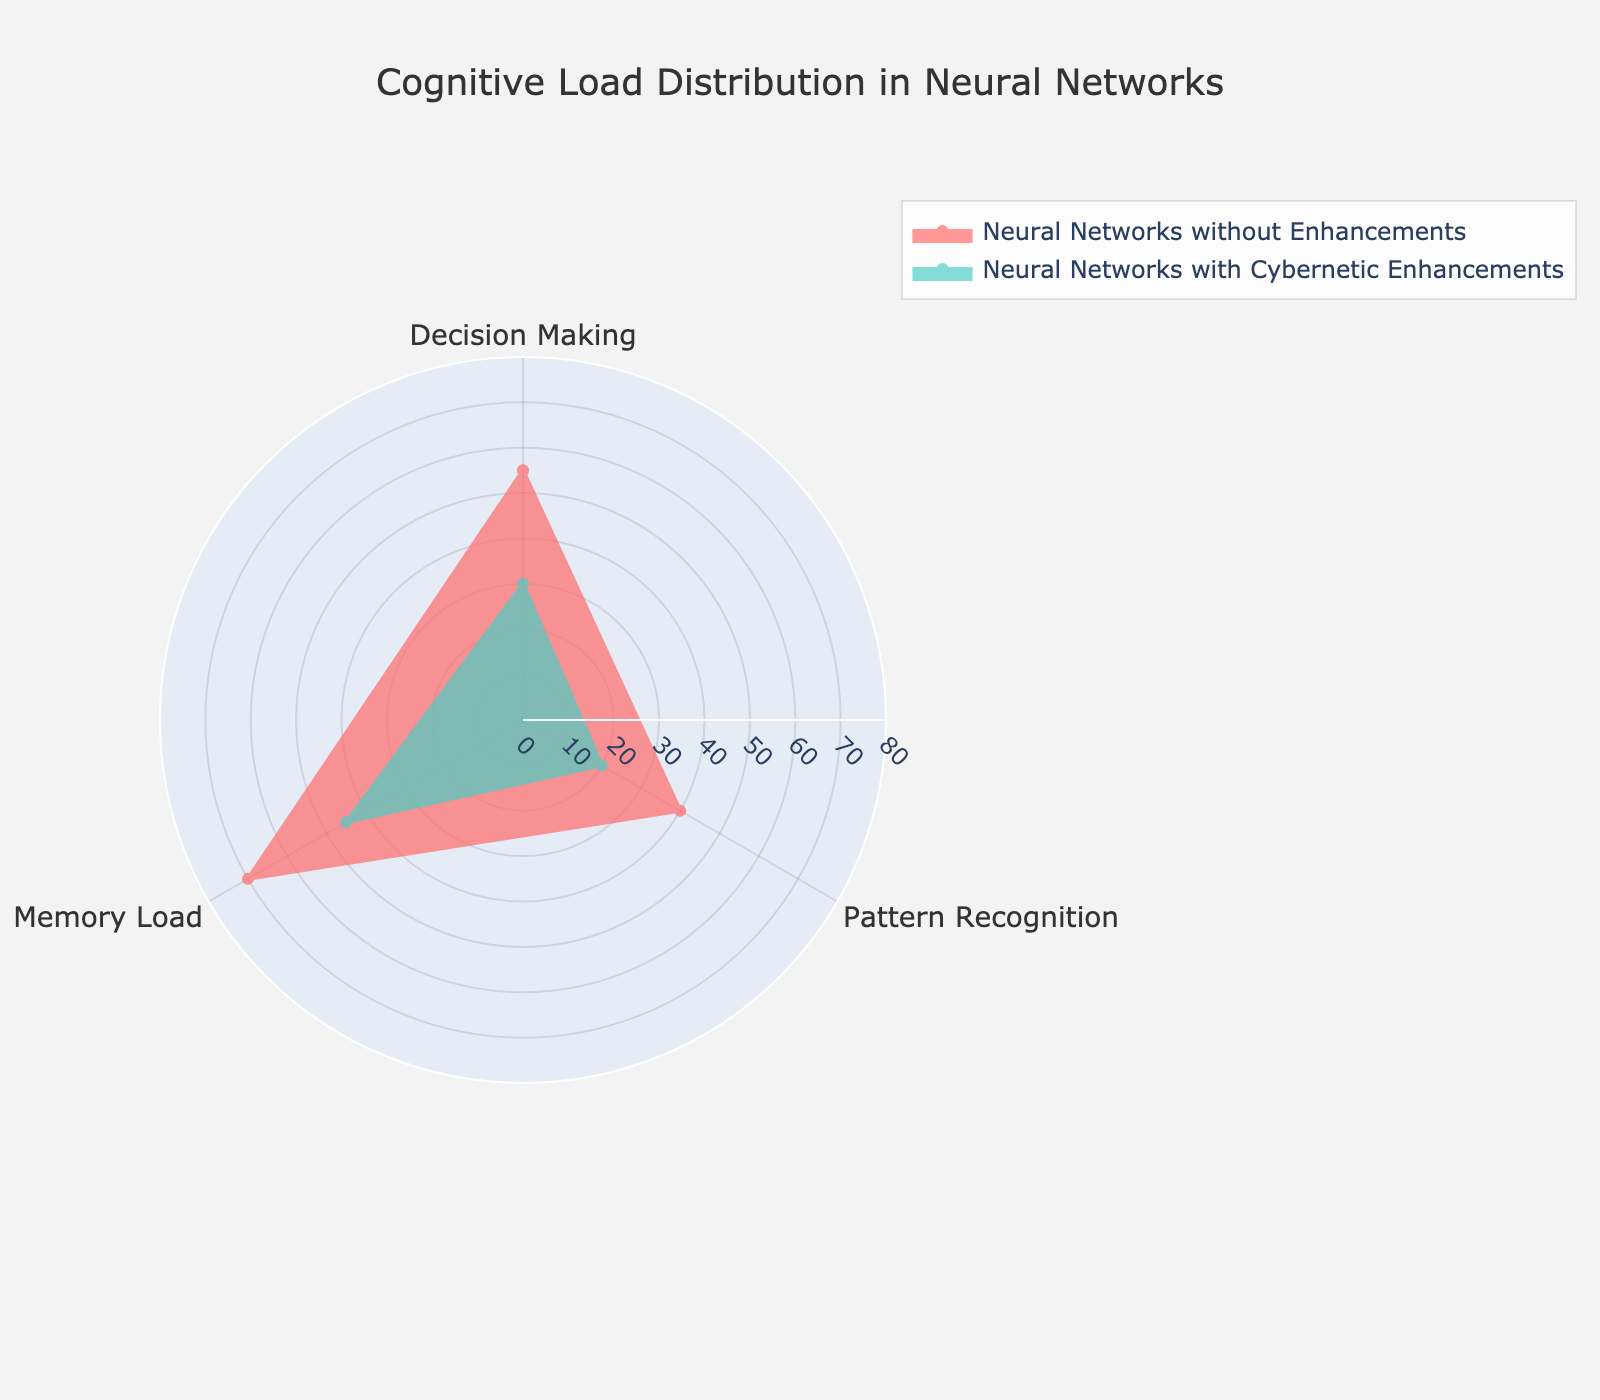what is the title of the chart? The title of the chart is displayed prominently at the top to provide context about the visualized data. It reads "Cognitive Load Distribution in Neural Networks".
Answer: Cognitive Load Distribution in Neural Networks what group does the color red represent? The red color in the chart represents the group "Neural Networks without Enhancements". This is usually indicated in the chart legend.
Answer: Neural Networks without Enhancements How many measures are compared in this chart? The chart compares three different measures: Decision Making, Pattern Recognition, and Memory Load. These are shown around the polar axis.
Answer: 3 Which measure has the highest cognitive load for Neural Networks with Cybernetic Enhancements? By looking at the area filled by the red and teal shapes, we can see that "Memory Load" has the highest cognitive load for Neural Networks with Cybernetic Enhancements, as it reaches the farthest from the center.
Answer: Memory Load How much higher is the Memory Load for Neural Networks without Enhancements compared to those with Cybernetic Enhancements? The Memory Load for Neural Networks without Enhancements is 70, whereas for those with Cybernetic Enhancements, it is 45. So, the difference is 70 - 45 = 25.
Answer: 25 Which group shows a lower cognitive load in Decision Making? The group "Neural Networks with Cybernetic Enhancements" shows a lower cognitive load in Decision Making with a value of 30, compared to "Neural Networks without Enhancements" which has a value of 55.
Answer: Neural Networks with Cybernetic Enhancements What is the average cognitive load for Neural Networks without Enhancements? To find the average, we sum up the cognitive loads for Decision Making (55), Pattern Recognition (40), and Memory Load (70), and divide by the number of measures (3). (55 + 40 + 70) / 3 = 165 / 3 = 55.
Answer: 55 Which group has a smaller variation in cognitive load across different measures? We can infer variation by looking at the differences in cognitive load values within each group. "Neural Networks with Cybernetic Enhancements" have cognitive loads of 30, 20, and 45, while "Neural Networks without Enhancements" have values of 55, 40, and 70. The variation appears smaller in the teal group as the range (45 - 20 = 25) is less than the range in the red group (70 - 40 = 30).
Answer: Neural Networks with Cybernetic Enhancements What is the combined cognitive load for Pattern Recognition across both groups? The cognitive load for Pattern Recognition is 40 for Neural Networks without Enhancements and 20 for those with Cybernetic Enhancements. The combined load is 40 + 20 = 60.
Answer: 60 